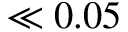<formula> <loc_0><loc_0><loc_500><loc_500>\ll 0 . 0 5</formula> 